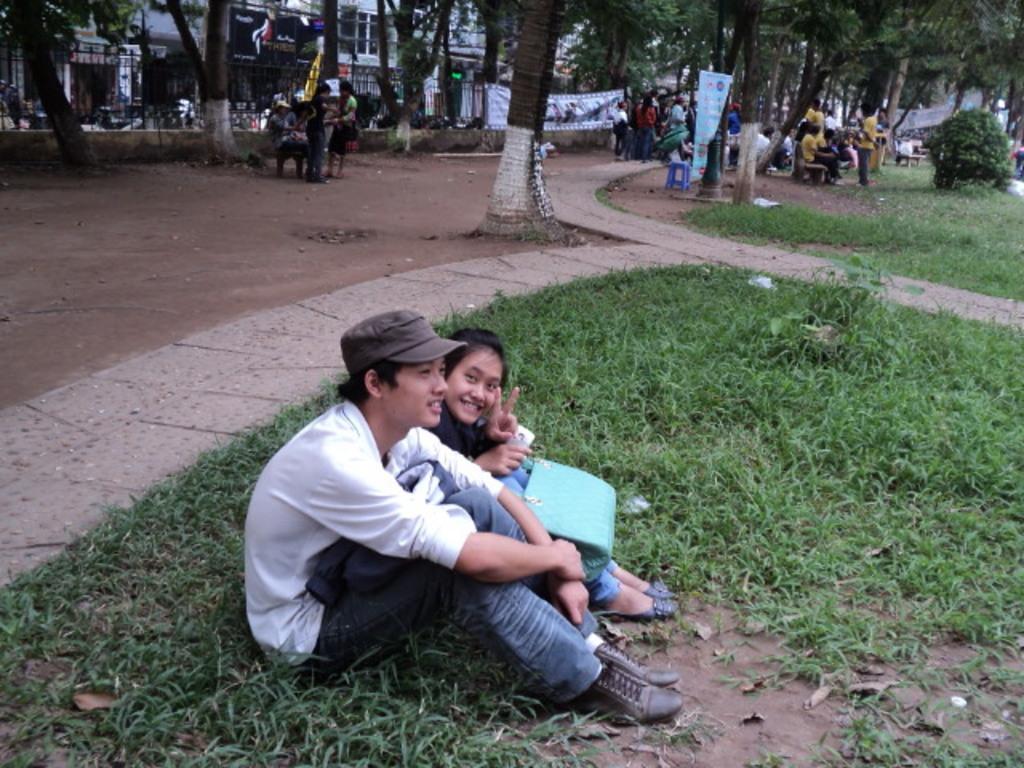Please provide a concise description of this image. As we can see in the image there are few people, benches, grass, plants, banners, trees and buildings. 